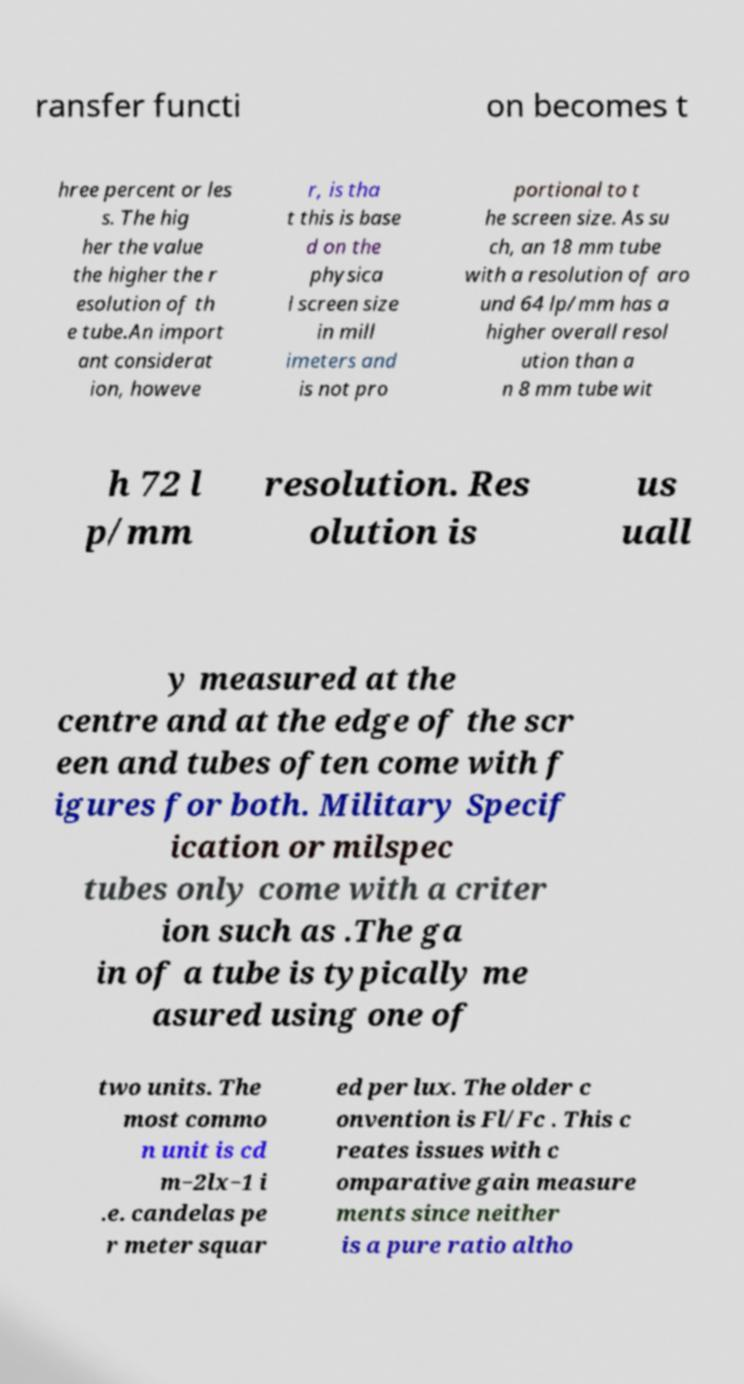What messages or text are displayed in this image? I need them in a readable, typed format. ransfer functi on becomes t hree percent or les s. The hig her the value the higher the r esolution of th e tube.An import ant considerat ion, howeve r, is tha t this is base d on the physica l screen size in mill imeters and is not pro portional to t he screen size. As su ch, an 18 mm tube with a resolution of aro und 64 lp/mm has a higher overall resol ution than a n 8 mm tube wit h 72 l p/mm resolution. Res olution is us uall y measured at the centre and at the edge of the scr een and tubes often come with f igures for both. Military Specif ication or milspec tubes only come with a criter ion such as .The ga in of a tube is typically me asured using one of two units. The most commo n unit is cd m−2lx−1 i .e. candelas pe r meter squar ed per lux. The older c onvention is Fl/Fc . This c reates issues with c omparative gain measure ments since neither is a pure ratio altho 